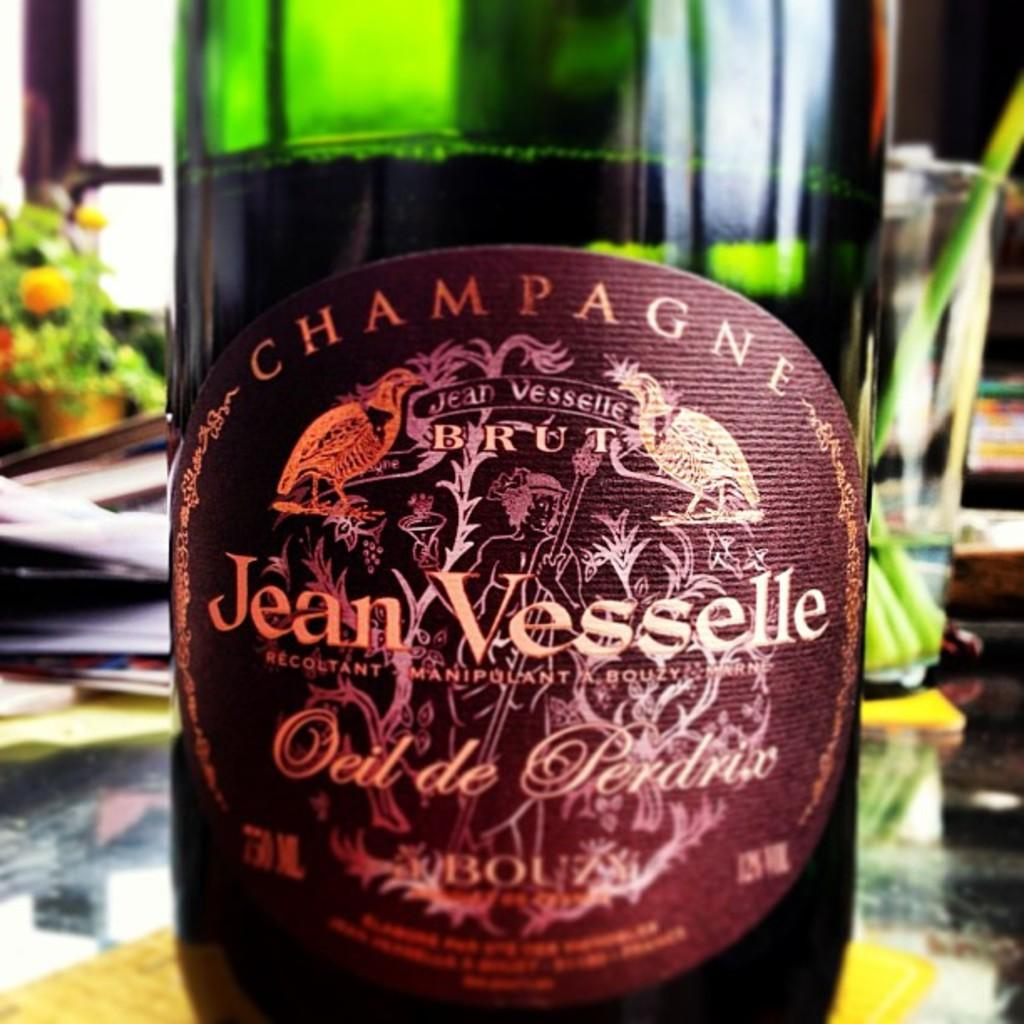<image>
Write a terse but informative summary of the picture. A bottle of Jean Vesselle has a maroon colored label. 